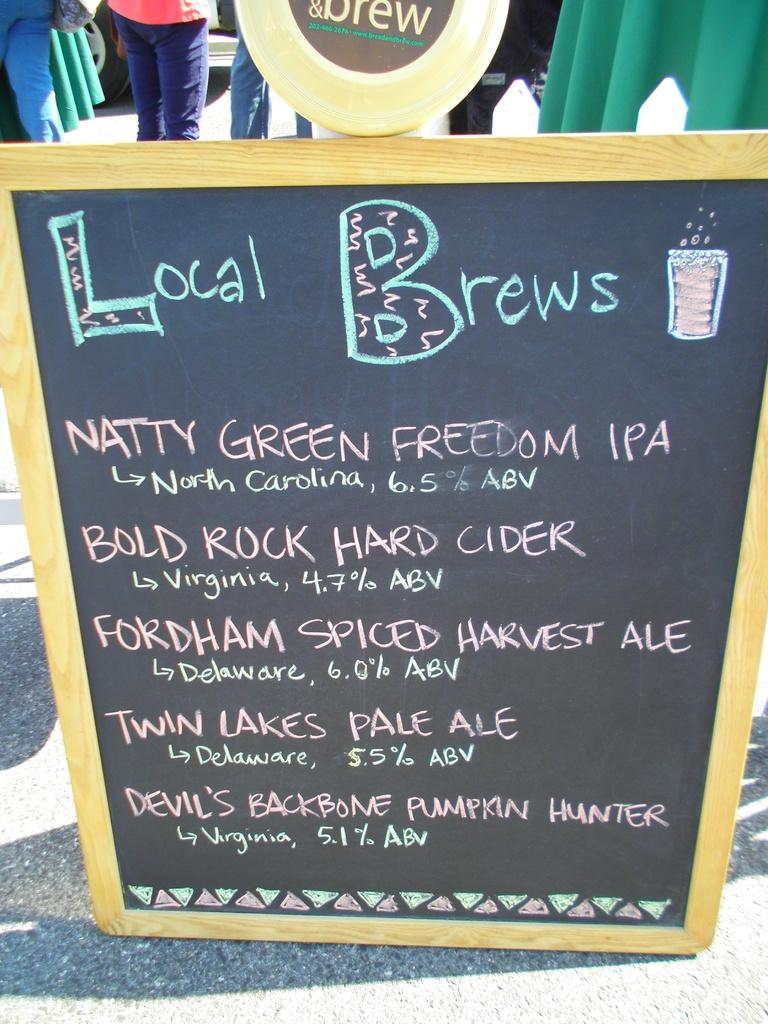What is the main object in the image? There is a board in the image. What is on the board? Something is written on the board. What can be seen in the background of the image? There is a group of people in the background of the image, and a vehicle is visible as well. How can you describe the people in the background? The people are wearing different color dresses. How many mines are visible in the image? There are no mines present in the image. What type of knowledge can be gained from the wing in the image? There is no wing present in the image, so no knowledge can be gained from it. 